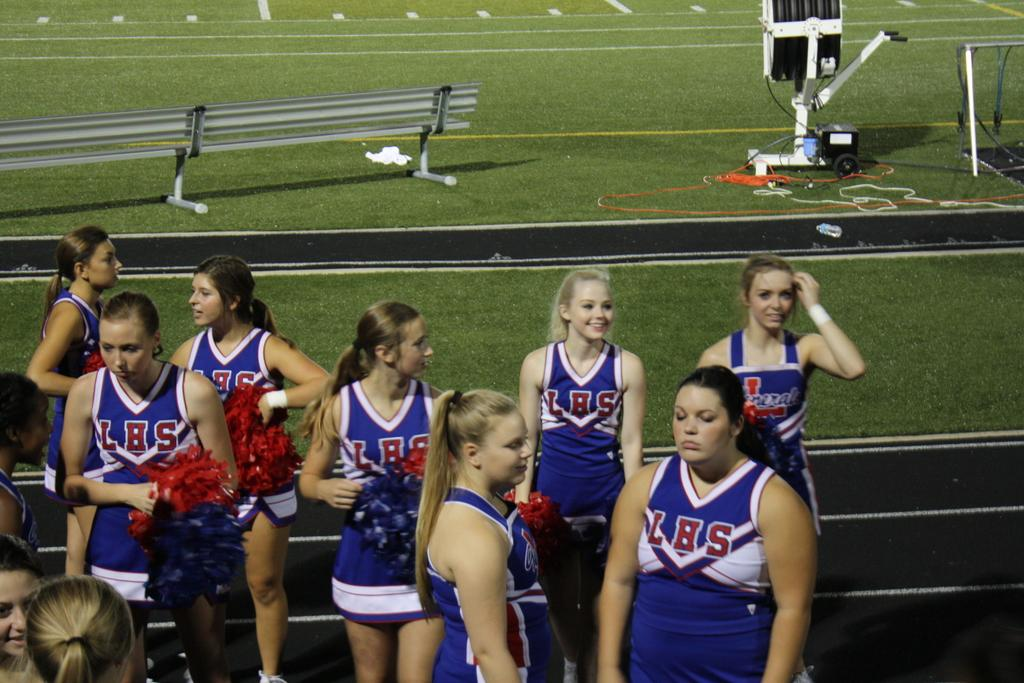<image>
Share a concise interpretation of the image provided. a group of cheerleaders with LBS on their outfits. 